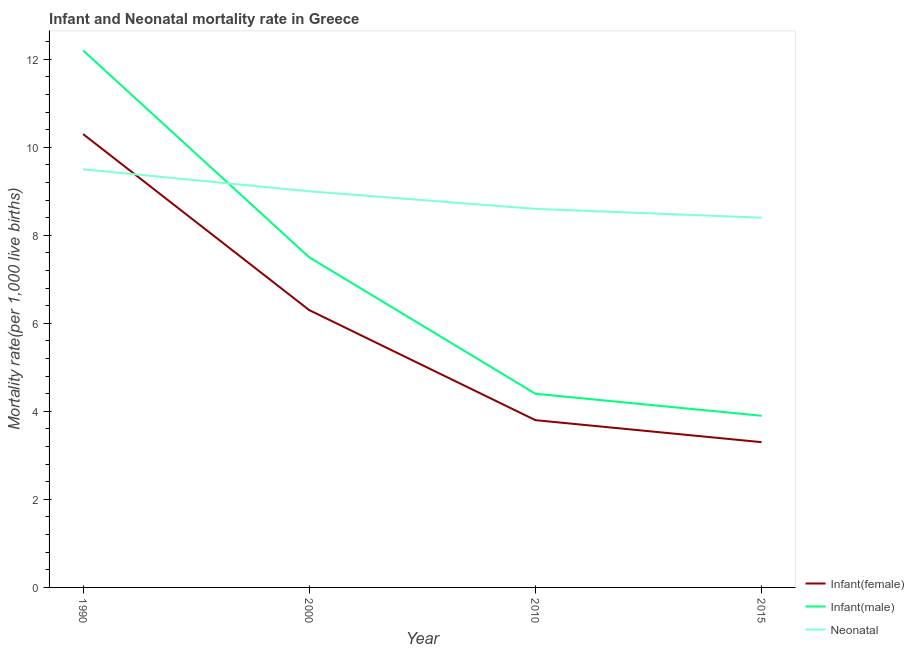Does the line corresponding to infant mortality rate(male) intersect with the line corresponding to neonatal mortality rate?
Make the answer very short. Yes. Is the number of lines equal to the number of legend labels?
Offer a very short reply. Yes. What is the infant mortality rate(female) in 1990?
Give a very brief answer. 10.3. In which year was the infant mortality rate(male) minimum?
Give a very brief answer. 2015. What is the total infant mortality rate(male) in the graph?
Your answer should be compact. 28. What is the difference between the neonatal mortality rate in 1990 and that in 2000?
Keep it short and to the point. 0.5. What is the difference between the neonatal mortality rate in 2015 and the infant mortality rate(female) in 1990?
Ensure brevity in your answer.  -1.9. What is the average infant mortality rate(male) per year?
Offer a very short reply. 7. What is the ratio of the infant mortality rate(male) in 1990 to that in 2010?
Your answer should be compact. 2.77. Is the neonatal mortality rate in 2000 less than that in 2010?
Your answer should be compact. No. What is the difference between the highest and the second highest infant mortality rate(female)?
Offer a terse response. 4. What is the difference between the highest and the lowest infant mortality rate(male)?
Your answer should be very brief. 8.3. In how many years, is the infant mortality rate(male) greater than the average infant mortality rate(male) taken over all years?
Provide a short and direct response. 2. Does the infant mortality rate(male) monotonically increase over the years?
Ensure brevity in your answer.  No. Is the infant mortality rate(female) strictly greater than the neonatal mortality rate over the years?
Keep it short and to the point. No. How many lines are there?
Offer a very short reply. 3. Does the graph contain any zero values?
Keep it short and to the point. No. Does the graph contain grids?
Offer a terse response. No. Where does the legend appear in the graph?
Make the answer very short. Bottom right. How many legend labels are there?
Provide a short and direct response. 3. How are the legend labels stacked?
Provide a short and direct response. Vertical. What is the title of the graph?
Offer a terse response. Infant and Neonatal mortality rate in Greece. Does "Natural Gas" appear as one of the legend labels in the graph?
Keep it short and to the point. No. What is the label or title of the Y-axis?
Ensure brevity in your answer.  Mortality rate(per 1,0 live births). What is the Mortality rate(per 1,000 live births) of Infant(female) in 1990?
Make the answer very short. 10.3. What is the Mortality rate(per 1,000 live births) in Neonatal  in 2000?
Offer a very short reply. 9. What is the Mortality rate(per 1,000 live births) of Neonatal  in 2010?
Offer a terse response. 8.6. What is the Mortality rate(per 1,000 live births) of Neonatal  in 2015?
Provide a succinct answer. 8.4. Across all years, what is the maximum Mortality rate(per 1,000 live births) in Infant(male)?
Your answer should be very brief. 12.2. Across all years, what is the maximum Mortality rate(per 1,000 live births) in Neonatal ?
Your answer should be compact. 9.5. Across all years, what is the minimum Mortality rate(per 1,000 live births) of Infant(female)?
Offer a very short reply. 3.3. Across all years, what is the minimum Mortality rate(per 1,000 live births) in Infant(male)?
Your answer should be compact. 3.9. Across all years, what is the minimum Mortality rate(per 1,000 live births) of Neonatal ?
Ensure brevity in your answer.  8.4. What is the total Mortality rate(per 1,000 live births) of Infant(female) in the graph?
Offer a very short reply. 23.7. What is the total Mortality rate(per 1,000 live births) of Neonatal  in the graph?
Provide a short and direct response. 35.5. What is the difference between the Mortality rate(per 1,000 live births) in Infant(female) in 1990 and that in 2000?
Make the answer very short. 4. What is the difference between the Mortality rate(per 1,000 live births) of Neonatal  in 1990 and that in 2010?
Provide a succinct answer. 0.9. What is the difference between the Mortality rate(per 1,000 live births) of Infant(female) in 1990 and that in 2015?
Provide a short and direct response. 7. What is the difference between the Mortality rate(per 1,000 live births) in Infant(male) in 1990 and that in 2015?
Your answer should be compact. 8.3. What is the difference between the Mortality rate(per 1,000 live births) in Neonatal  in 1990 and that in 2015?
Provide a short and direct response. 1.1. What is the difference between the Mortality rate(per 1,000 live births) in Neonatal  in 2000 and that in 2010?
Ensure brevity in your answer.  0.4. What is the difference between the Mortality rate(per 1,000 live births) in Infant(female) in 2000 and that in 2015?
Provide a short and direct response. 3. What is the difference between the Mortality rate(per 1,000 live births) in Infant(male) in 2000 and that in 2015?
Your answer should be very brief. 3.6. What is the difference between the Mortality rate(per 1,000 live births) of Infant(male) in 2010 and that in 2015?
Provide a short and direct response. 0.5. What is the difference between the Mortality rate(per 1,000 live births) in Neonatal  in 2010 and that in 2015?
Your answer should be compact. 0.2. What is the difference between the Mortality rate(per 1,000 live births) of Infant(female) in 1990 and the Mortality rate(per 1,000 live births) of Infant(male) in 2000?
Your answer should be very brief. 2.8. What is the difference between the Mortality rate(per 1,000 live births) in Infant(female) in 1990 and the Mortality rate(per 1,000 live births) in Infant(male) in 2010?
Offer a terse response. 5.9. What is the difference between the Mortality rate(per 1,000 live births) in Infant(female) in 1990 and the Mortality rate(per 1,000 live births) in Neonatal  in 2010?
Offer a very short reply. 1.7. What is the difference between the Mortality rate(per 1,000 live births) in Infant(female) in 1990 and the Mortality rate(per 1,000 live births) in Infant(male) in 2015?
Ensure brevity in your answer.  6.4. What is the difference between the Mortality rate(per 1,000 live births) in Infant(female) in 1990 and the Mortality rate(per 1,000 live births) in Neonatal  in 2015?
Your answer should be very brief. 1.9. What is the difference between the Mortality rate(per 1,000 live births) in Infant(male) in 2000 and the Mortality rate(per 1,000 live births) in Neonatal  in 2010?
Provide a succinct answer. -1.1. What is the difference between the Mortality rate(per 1,000 live births) of Infant(female) in 2000 and the Mortality rate(per 1,000 live births) of Infant(male) in 2015?
Make the answer very short. 2.4. What is the difference between the Mortality rate(per 1,000 live births) of Infant(female) in 2010 and the Mortality rate(per 1,000 live births) of Infant(male) in 2015?
Provide a short and direct response. -0.1. What is the difference between the Mortality rate(per 1,000 live births) in Infant(female) in 2010 and the Mortality rate(per 1,000 live births) in Neonatal  in 2015?
Your answer should be very brief. -4.6. What is the difference between the Mortality rate(per 1,000 live births) in Infant(male) in 2010 and the Mortality rate(per 1,000 live births) in Neonatal  in 2015?
Offer a very short reply. -4. What is the average Mortality rate(per 1,000 live births) in Infant(female) per year?
Offer a terse response. 5.92. What is the average Mortality rate(per 1,000 live births) of Neonatal  per year?
Give a very brief answer. 8.88. In the year 1990, what is the difference between the Mortality rate(per 1,000 live births) in Infant(female) and Mortality rate(per 1,000 live births) in Neonatal ?
Provide a short and direct response. 0.8. In the year 2000, what is the difference between the Mortality rate(per 1,000 live births) in Infant(female) and Mortality rate(per 1,000 live births) in Neonatal ?
Offer a very short reply. -2.7. In the year 2000, what is the difference between the Mortality rate(per 1,000 live births) in Infant(male) and Mortality rate(per 1,000 live births) in Neonatal ?
Keep it short and to the point. -1.5. In the year 2010, what is the difference between the Mortality rate(per 1,000 live births) in Infant(female) and Mortality rate(per 1,000 live births) in Infant(male)?
Offer a very short reply. -0.6. In the year 2010, what is the difference between the Mortality rate(per 1,000 live births) of Infant(female) and Mortality rate(per 1,000 live births) of Neonatal ?
Provide a short and direct response. -4.8. What is the ratio of the Mortality rate(per 1,000 live births) in Infant(female) in 1990 to that in 2000?
Ensure brevity in your answer.  1.63. What is the ratio of the Mortality rate(per 1,000 live births) in Infant(male) in 1990 to that in 2000?
Make the answer very short. 1.63. What is the ratio of the Mortality rate(per 1,000 live births) of Neonatal  in 1990 to that in 2000?
Provide a short and direct response. 1.06. What is the ratio of the Mortality rate(per 1,000 live births) in Infant(female) in 1990 to that in 2010?
Offer a very short reply. 2.71. What is the ratio of the Mortality rate(per 1,000 live births) of Infant(male) in 1990 to that in 2010?
Make the answer very short. 2.77. What is the ratio of the Mortality rate(per 1,000 live births) in Neonatal  in 1990 to that in 2010?
Provide a succinct answer. 1.1. What is the ratio of the Mortality rate(per 1,000 live births) in Infant(female) in 1990 to that in 2015?
Provide a succinct answer. 3.12. What is the ratio of the Mortality rate(per 1,000 live births) in Infant(male) in 1990 to that in 2015?
Offer a terse response. 3.13. What is the ratio of the Mortality rate(per 1,000 live births) of Neonatal  in 1990 to that in 2015?
Give a very brief answer. 1.13. What is the ratio of the Mortality rate(per 1,000 live births) of Infant(female) in 2000 to that in 2010?
Ensure brevity in your answer.  1.66. What is the ratio of the Mortality rate(per 1,000 live births) of Infant(male) in 2000 to that in 2010?
Provide a succinct answer. 1.7. What is the ratio of the Mortality rate(per 1,000 live births) in Neonatal  in 2000 to that in 2010?
Your answer should be compact. 1.05. What is the ratio of the Mortality rate(per 1,000 live births) in Infant(female) in 2000 to that in 2015?
Your answer should be compact. 1.91. What is the ratio of the Mortality rate(per 1,000 live births) in Infant(male) in 2000 to that in 2015?
Provide a short and direct response. 1.92. What is the ratio of the Mortality rate(per 1,000 live births) of Neonatal  in 2000 to that in 2015?
Offer a very short reply. 1.07. What is the ratio of the Mortality rate(per 1,000 live births) of Infant(female) in 2010 to that in 2015?
Provide a succinct answer. 1.15. What is the ratio of the Mortality rate(per 1,000 live births) of Infant(male) in 2010 to that in 2015?
Keep it short and to the point. 1.13. What is the ratio of the Mortality rate(per 1,000 live births) of Neonatal  in 2010 to that in 2015?
Ensure brevity in your answer.  1.02. What is the difference between the highest and the second highest Mortality rate(per 1,000 live births) in Infant(female)?
Offer a terse response. 4. What is the difference between the highest and the lowest Mortality rate(per 1,000 live births) of Infant(female)?
Ensure brevity in your answer.  7. What is the difference between the highest and the lowest Mortality rate(per 1,000 live births) of Infant(male)?
Provide a short and direct response. 8.3. 